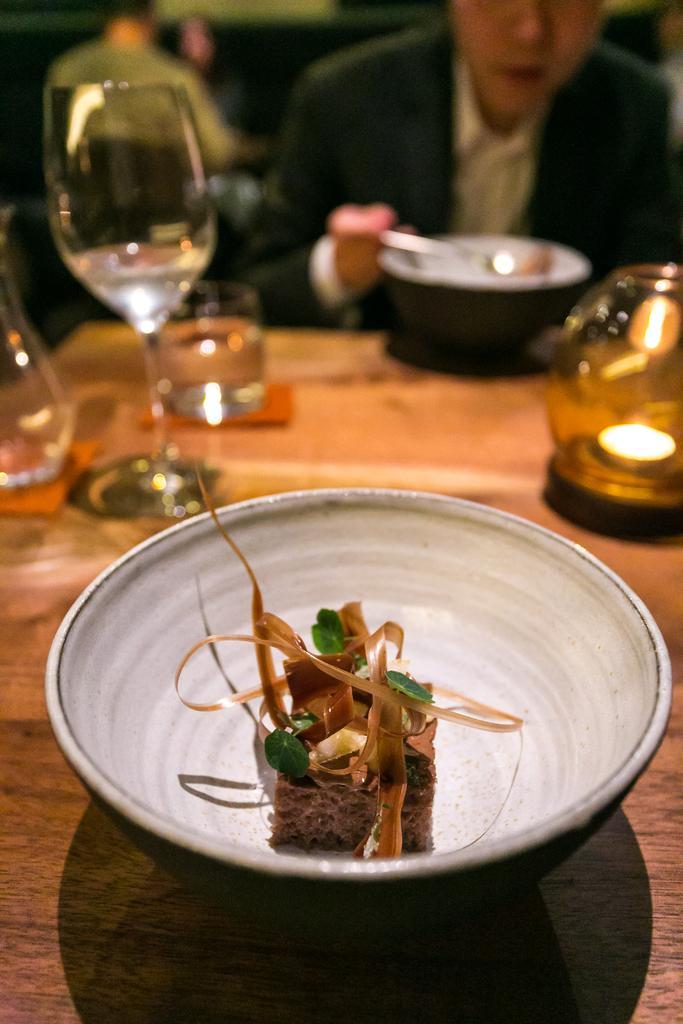Can you describe this image briefly? In this picture we can see some food in the white plate, placed on the dining table. Behind we can see a man sitting and eating the food. 